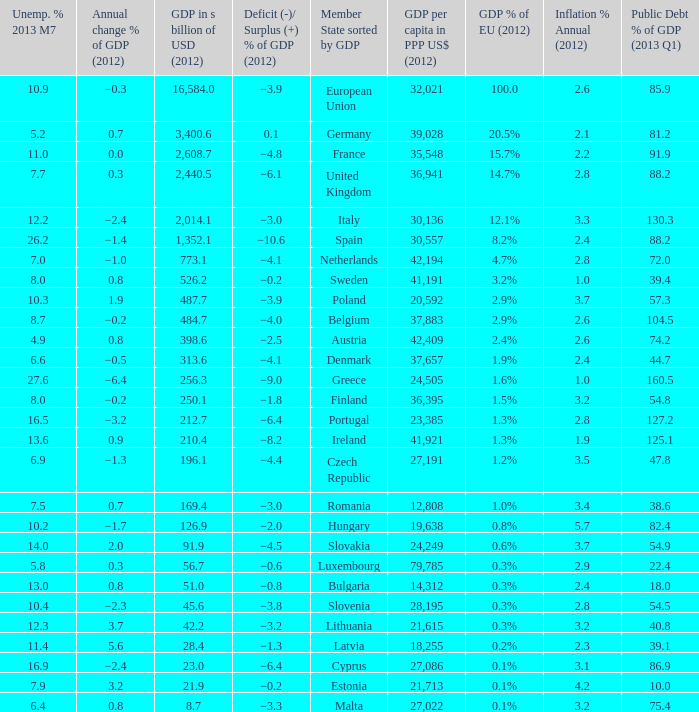What is the average public debt % of GDP in 2013 Q1 of the country with a member slate sorted by GDP of Czech Republic and a GDP per capita in PPP US dollars in 2012 greater than 27,191? None. 